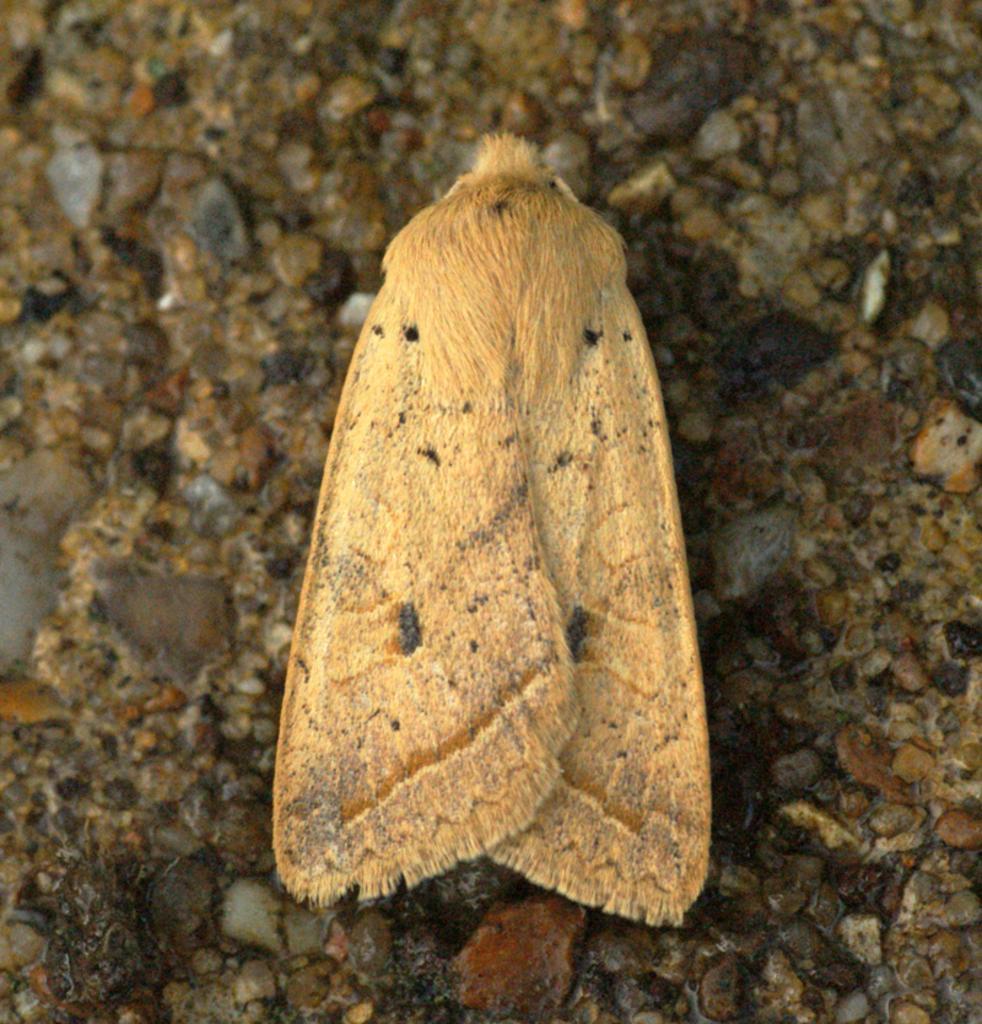In one or two sentences, can you explain what this image depicts? In this picture there is an insect on the sand. 